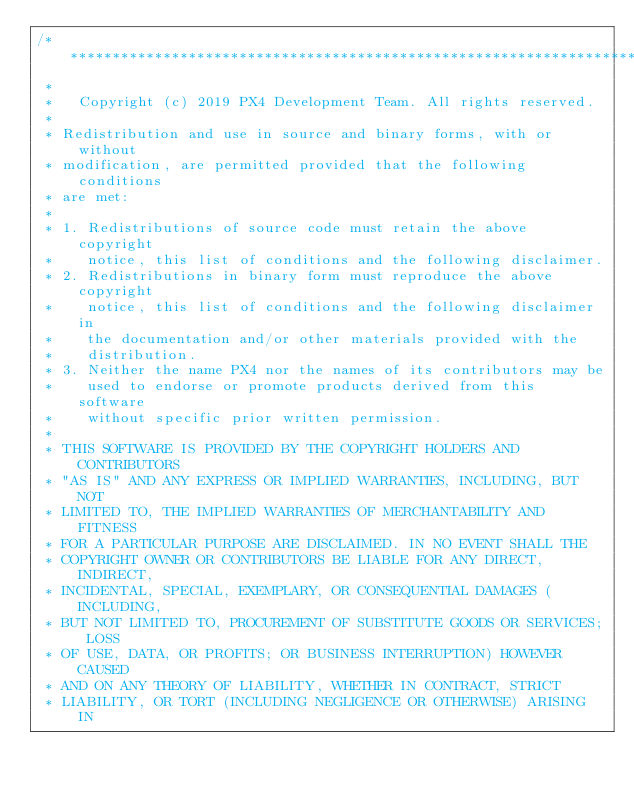Convert code to text. <code><loc_0><loc_0><loc_500><loc_500><_C++_>/****************************************************************************
 *
 *   Copyright (c) 2019 PX4 Development Team. All rights reserved.
 *
 * Redistribution and use in source and binary forms, with or without
 * modification, are permitted provided that the following conditions
 * are met:
 *
 * 1. Redistributions of source code must retain the above copyright
 *    notice, this list of conditions and the following disclaimer.
 * 2. Redistributions in binary form must reproduce the above copyright
 *    notice, this list of conditions and the following disclaimer in
 *    the documentation and/or other materials provided with the
 *    distribution.
 * 3. Neither the name PX4 nor the names of its contributors may be
 *    used to endorse or promote products derived from this software
 *    without specific prior written permission.
 *
 * THIS SOFTWARE IS PROVIDED BY THE COPYRIGHT HOLDERS AND CONTRIBUTORS
 * "AS IS" AND ANY EXPRESS OR IMPLIED WARRANTIES, INCLUDING, BUT NOT
 * LIMITED TO, THE IMPLIED WARRANTIES OF MERCHANTABILITY AND FITNESS
 * FOR A PARTICULAR PURPOSE ARE DISCLAIMED. IN NO EVENT SHALL THE
 * COPYRIGHT OWNER OR CONTRIBUTORS BE LIABLE FOR ANY DIRECT, INDIRECT,
 * INCIDENTAL, SPECIAL, EXEMPLARY, OR CONSEQUENTIAL DAMAGES (INCLUDING,
 * BUT NOT LIMITED TO, PROCUREMENT OF SUBSTITUTE GOODS OR SERVICES; LOSS
 * OF USE, DATA, OR PROFITS; OR BUSINESS INTERRUPTION) HOWEVER CAUSED
 * AND ON ANY THEORY OF LIABILITY, WHETHER IN CONTRACT, STRICT
 * LIABILITY, OR TORT (INCLUDING NEGLIGENCE OR OTHERWISE) ARISING IN</code> 